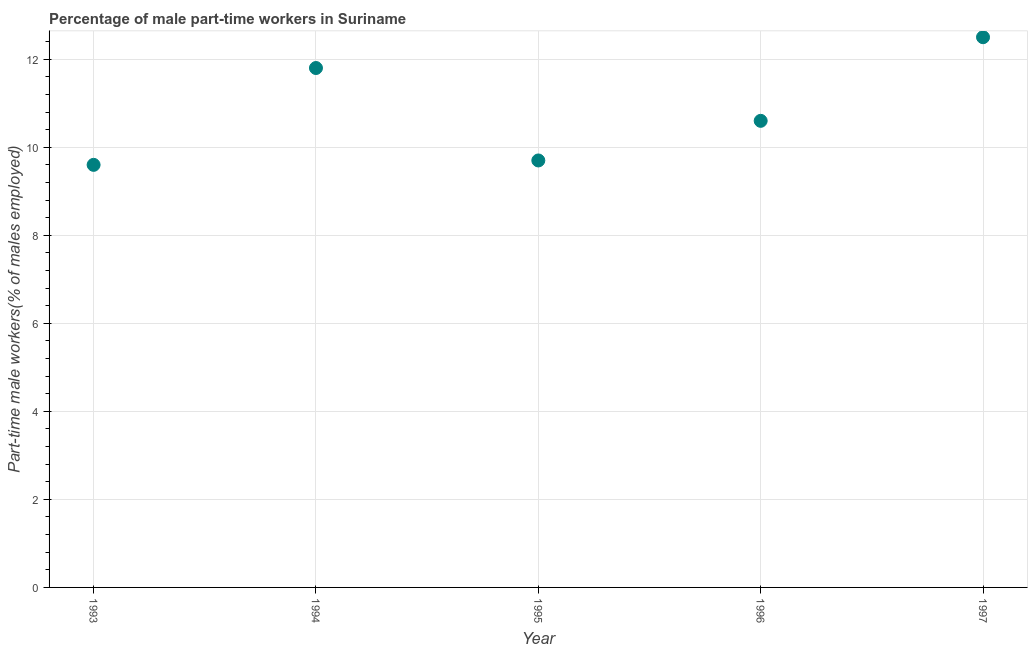What is the percentage of part-time male workers in 1996?
Your answer should be compact. 10.6. Across all years, what is the minimum percentage of part-time male workers?
Ensure brevity in your answer.  9.6. In which year was the percentage of part-time male workers maximum?
Your response must be concise. 1997. What is the sum of the percentage of part-time male workers?
Your response must be concise. 54.2. What is the difference between the percentage of part-time male workers in 1995 and 1997?
Ensure brevity in your answer.  -2.8. What is the average percentage of part-time male workers per year?
Make the answer very short. 10.84. What is the median percentage of part-time male workers?
Give a very brief answer. 10.6. Do a majority of the years between 1993 and 1994 (inclusive) have percentage of part-time male workers greater than 8 %?
Offer a terse response. Yes. What is the ratio of the percentage of part-time male workers in 1995 to that in 1997?
Ensure brevity in your answer.  0.78. Is the percentage of part-time male workers in 1993 less than that in 1996?
Provide a short and direct response. Yes. What is the difference between the highest and the second highest percentage of part-time male workers?
Provide a succinct answer. 0.7. Is the sum of the percentage of part-time male workers in 1995 and 1996 greater than the maximum percentage of part-time male workers across all years?
Provide a succinct answer. Yes. What is the difference between the highest and the lowest percentage of part-time male workers?
Provide a short and direct response. 2.9. Does the percentage of part-time male workers monotonically increase over the years?
Keep it short and to the point. No. Does the graph contain any zero values?
Give a very brief answer. No. Does the graph contain grids?
Provide a short and direct response. Yes. What is the title of the graph?
Provide a short and direct response. Percentage of male part-time workers in Suriname. What is the label or title of the X-axis?
Offer a very short reply. Year. What is the label or title of the Y-axis?
Provide a succinct answer. Part-time male workers(% of males employed). What is the Part-time male workers(% of males employed) in 1993?
Offer a terse response. 9.6. What is the Part-time male workers(% of males employed) in 1994?
Your answer should be compact. 11.8. What is the Part-time male workers(% of males employed) in 1995?
Give a very brief answer. 9.7. What is the Part-time male workers(% of males employed) in 1996?
Provide a succinct answer. 10.6. What is the Part-time male workers(% of males employed) in 1997?
Provide a short and direct response. 12.5. What is the difference between the Part-time male workers(% of males employed) in 1993 and 1997?
Give a very brief answer. -2.9. What is the difference between the Part-time male workers(% of males employed) in 1994 and 1996?
Your answer should be very brief. 1.2. What is the difference between the Part-time male workers(% of males employed) in 1994 and 1997?
Provide a short and direct response. -0.7. What is the difference between the Part-time male workers(% of males employed) in 1995 and 1996?
Offer a very short reply. -0.9. What is the difference between the Part-time male workers(% of males employed) in 1995 and 1997?
Give a very brief answer. -2.8. What is the difference between the Part-time male workers(% of males employed) in 1996 and 1997?
Your response must be concise. -1.9. What is the ratio of the Part-time male workers(% of males employed) in 1993 to that in 1994?
Your response must be concise. 0.81. What is the ratio of the Part-time male workers(% of males employed) in 1993 to that in 1996?
Keep it short and to the point. 0.91. What is the ratio of the Part-time male workers(% of males employed) in 1993 to that in 1997?
Offer a terse response. 0.77. What is the ratio of the Part-time male workers(% of males employed) in 1994 to that in 1995?
Offer a terse response. 1.22. What is the ratio of the Part-time male workers(% of males employed) in 1994 to that in 1996?
Your response must be concise. 1.11. What is the ratio of the Part-time male workers(% of males employed) in 1994 to that in 1997?
Your answer should be compact. 0.94. What is the ratio of the Part-time male workers(% of males employed) in 1995 to that in 1996?
Your answer should be very brief. 0.92. What is the ratio of the Part-time male workers(% of males employed) in 1995 to that in 1997?
Provide a succinct answer. 0.78. What is the ratio of the Part-time male workers(% of males employed) in 1996 to that in 1997?
Provide a succinct answer. 0.85. 